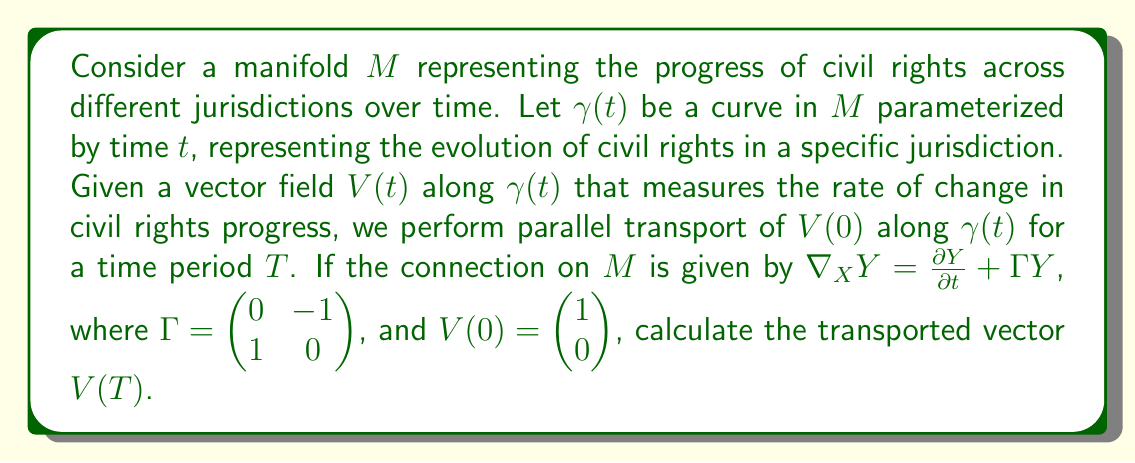What is the answer to this math problem? To solve this problem, we'll follow these steps:

1) The parallel transport equation is given by:

   $$\frac{DV}{dt} = \nabla_{\dot{\gamma}} V = 0$$

2) Using the given connection, we can expand this equation:

   $$\frac{\partial V}{\partial t} + \Gamma V = 0$$

3) Let $V(t) = \begin{pmatrix} x(t) \\ y(t) \end{pmatrix}$. Substituting this into the equation:

   $$\begin{pmatrix} x'(t) \\ y'(t) \end{pmatrix} + \begin{pmatrix} 0 & -1 \\ 1 & 0 \end{pmatrix} \begin{pmatrix} x(t) \\ y(t) \end{pmatrix} = \begin{pmatrix} 0 \\ 0 \end{pmatrix}$$

4) This gives us a system of differential equations:

   $$\begin{cases}
   x'(t) - y(t) = 0 \\
   y'(t) + x(t) = 0
   \end{cases}$$

5) Differentiating the first equation and substituting the second:

   $$x''(t) = y'(t) = -x(t)$$

6) This is the equation for simple harmonic motion. The general solution is:

   $$x(t) = A \cos(t) + B \sin(t)$$

7) From this, we can derive $y(t)$:

   $$y(t) = x'(t) = -A \sin(t) + B \cos(t)$$

8) Using the initial condition $V(0) = \begin{pmatrix} 1 \\ 0 \end{pmatrix}$, we can determine $A$ and $B$:

   $$\begin{cases}
   A = 1 \\
   B = 0
   \end{cases}$$

9) Therefore, the solution is:

   $$V(t) = \begin{pmatrix} \cos(t) \\ -\sin(t) \end{pmatrix}$$

10) At time $T$, the transported vector is:

    $$V(T) = \begin{pmatrix} \cos(T) \\ -\sin(T) \end{pmatrix}$$
Answer: $V(T) = \begin{pmatrix} \cos(T) \\ -\sin(T) \end{pmatrix}$ 